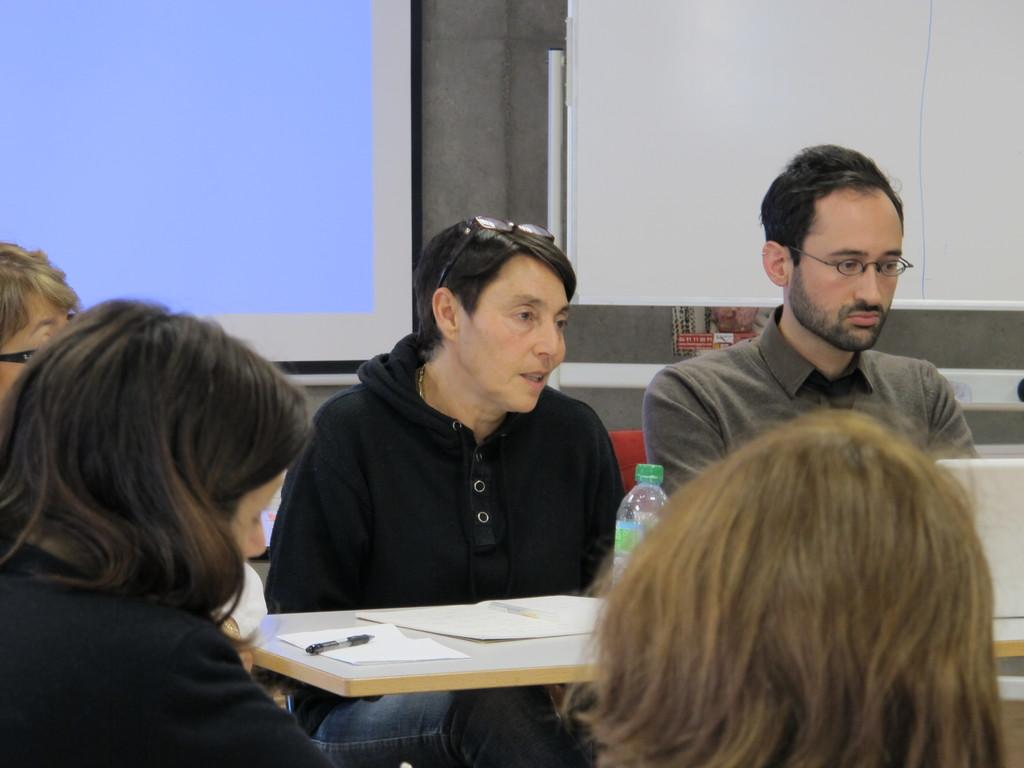How many people are present in the image? There are five persons in the image. What is located in front of the persons? There is a table in front of the persons. What items can be seen on the table? There are papers, a pen, and a bottle on the table. What can be seen in the background of the image? There is a screen and a wall in the background of the image. How many kittens are playing with the balloon in the image? There are no kittens or balloons present in the image. What type of animal can be seen interacting with the persons in the image? There are no animals visible in the image; only the five persons, the table, and the background elements are present. 